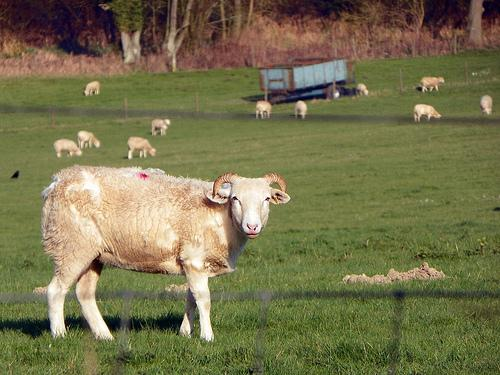Question: what is the animal seen?
Choices:
A. Donkey.
B. Horses.
C. Elephants.
D. Sheep.
Answer with the letter. Answer: D Question: what is the color of the grass?
Choices:
A. Brown.
B. Green.
C. Beige.
D. Yellow.
Answer with the letter. Answer: B Question: what is at the back of the picture?
Choices:
A. Trees.
B. Buildings.
C. Mountains.
D. Clouds.
Answer with the letter. Answer: A Question: where is the shadow?
Choices:
A. On the car.
B. Behind the person.
C. In the ground.
D. By the curb.
Answer with the letter. Answer: C 